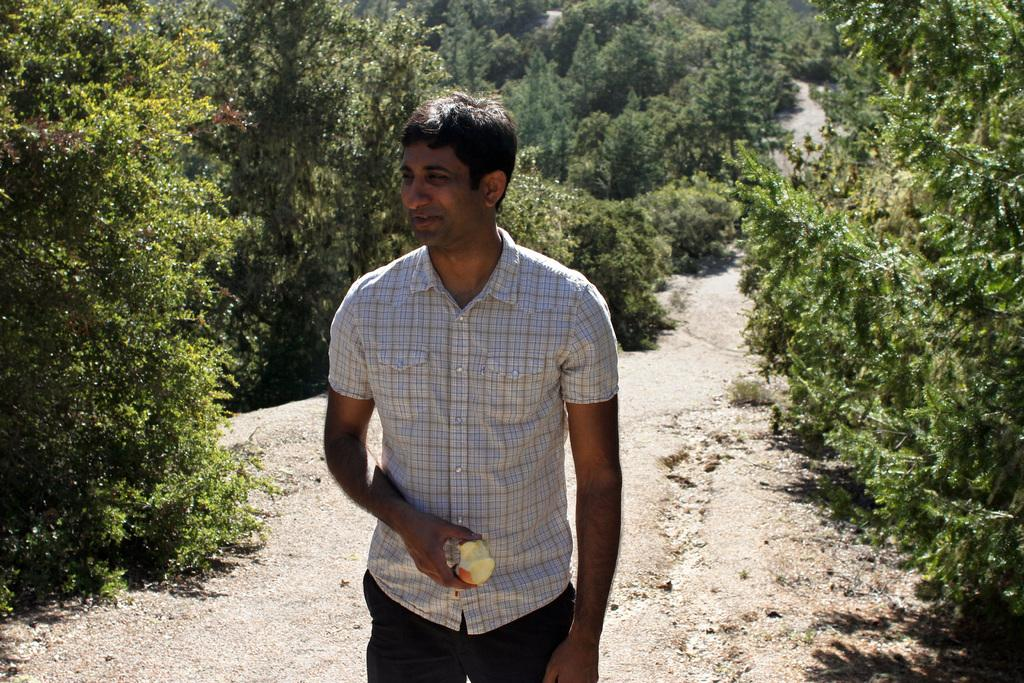What is the man in the image doing? The man is standing in the image. What is the man holding in the image? The man is holding an apple. What can be seen in the background of the image? There are trees and plants in the backdrop of the image. What type of boat can be seen in the image? There is no boat present in the image. Which actor is playing the role of the man in the image? The image does not depict a scene from a movie or play, so there is no actor portraying the man. 